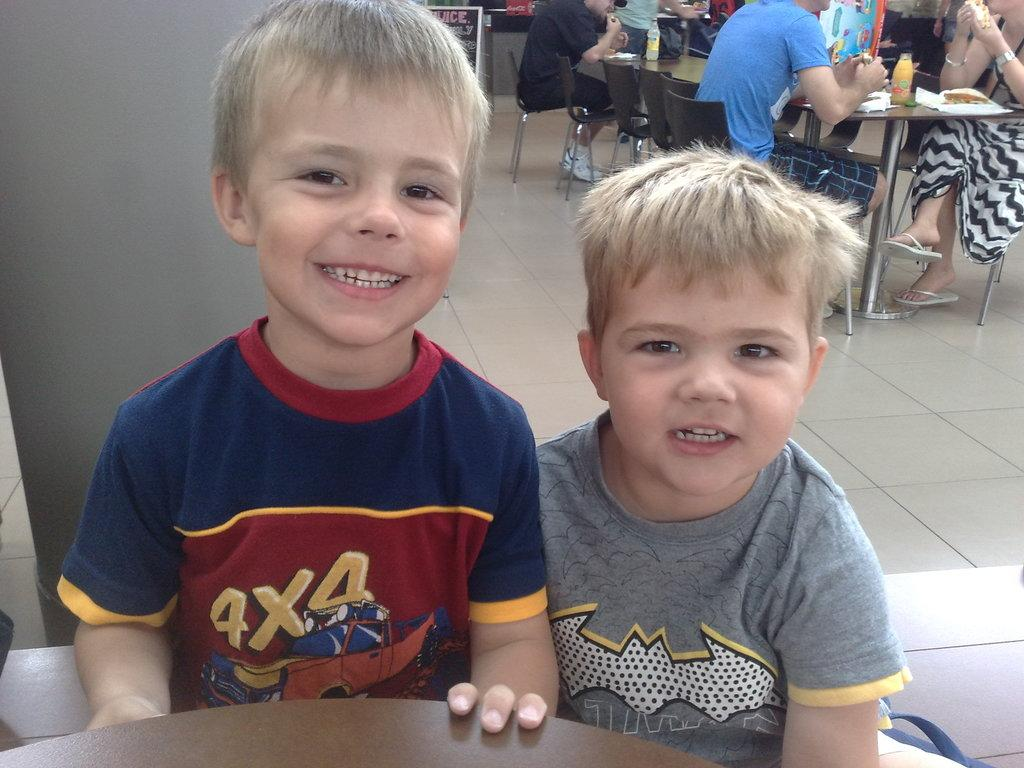What are the persons in the image doing? The persons in the image are sitting on chairs. What can be seen on the table in the image? There are bottles and food on the table. What is visible beneath the persons and table? There is a floor visible in the image. What architectural feature is present behind the two persons? There is a pillar behind the two persons. What type of plants can be seen growing on the persons' heads in the image? There are no plants visible on the persons' heads in the image. 